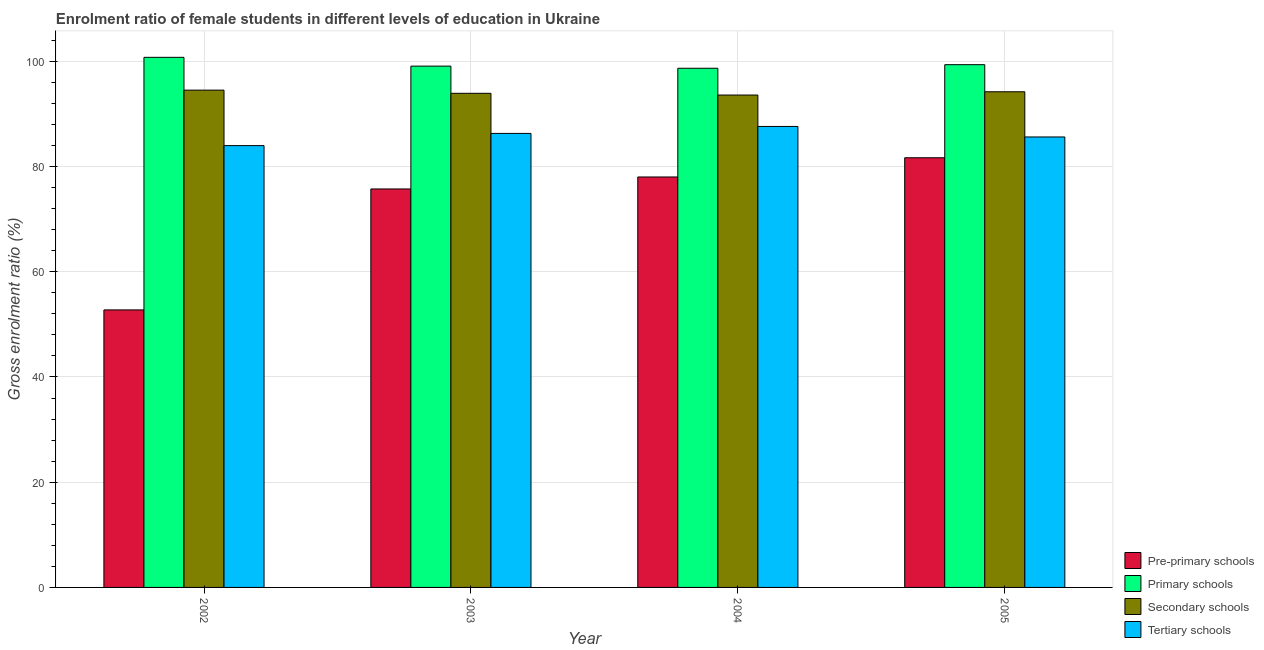How many bars are there on the 1st tick from the right?
Ensure brevity in your answer.  4. What is the label of the 3rd group of bars from the left?
Give a very brief answer. 2004. In how many cases, is the number of bars for a given year not equal to the number of legend labels?
Your answer should be very brief. 0. What is the gross enrolment ratio(male) in pre-primary schools in 2005?
Your answer should be compact. 81.67. Across all years, what is the maximum gross enrolment ratio(male) in primary schools?
Provide a succinct answer. 100.76. Across all years, what is the minimum gross enrolment ratio(male) in tertiary schools?
Offer a terse response. 83.98. In which year was the gross enrolment ratio(male) in tertiary schools maximum?
Make the answer very short. 2004. What is the total gross enrolment ratio(male) in tertiary schools in the graph?
Your answer should be very brief. 343.53. What is the difference between the gross enrolment ratio(male) in pre-primary schools in 2003 and that in 2004?
Your answer should be compact. -2.28. What is the difference between the gross enrolment ratio(male) in primary schools in 2005 and the gross enrolment ratio(male) in pre-primary schools in 2002?
Provide a short and direct response. -1.4. What is the average gross enrolment ratio(male) in tertiary schools per year?
Provide a short and direct response. 85.88. In how many years, is the gross enrolment ratio(male) in tertiary schools greater than 36 %?
Your response must be concise. 4. What is the ratio of the gross enrolment ratio(male) in pre-primary schools in 2004 to that in 2005?
Your answer should be compact. 0.96. What is the difference between the highest and the second highest gross enrolment ratio(male) in secondary schools?
Provide a succinct answer. 0.31. What is the difference between the highest and the lowest gross enrolment ratio(male) in primary schools?
Keep it short and to the point. 2.08. In how many years, is the gross enrolment ratio(male) in secondary schools greater than the average gross enrolment ratio(male) in secondary schools taken over all years?
Provide a short and direct response. 2. What does the 1st bar from the left in 2002 represents?
Ensure brevity in your answer.  Pre-primary schools. What does the 4th bar from the right in 2003 represents?
Ensure brevity in your answer.  Pre-primary schools. How many bars are there?
Give a very brief answer. 16. Are the values on the major ticks of Y-axis written in scientific E-notation?
Offer a terse response. No. Does the graph contain any zero values?
Offer a very short reply. No. Where does the legend appear in the graph?
Offer a very short reply. Bottom right. How many legend labels are there?
Your response must be concise. 4. How are the legend labels stacked?
Your answer should be very brief. Vertical. What is the title of the graph?
Provide a short and direct response. Enrolment ratio of female students in different levels of education in Ukraine. What is the label or title of the X-axis?
Make the answer very short. Year. What is the label or title of the Y-axis?
Your answer should be compact. Gross enrolment ratio (%). What is the Gross enrolment ratio (%) of Pre-primary schools in 2002?
Make the answer very short. 52.75. What is the Gross enrolment ratio (%) of Primary schools in 2002?
Ensure brevity in your answer.  100.76. What is the Gross enrolment ratio (%) of Secondary schools in 2002?
Your answer should be very brief. 94.53. What is the Gross enrolment ratio (%) in Tertiary schools in 2002?
Keep it short and to the point. 83.98. What is the Gross enrolment ratio (%) of Pre-primary schools in 2003?
Keep it short and to the point. 75.74. What is the Gross enrolment ratio (%) in Primary schools in 2003?
Give a very brief answer. 99.09. What is the Gross enrolment ratio (%) of Secondary schools in 2003?
Make the answer very short. 93.92. What is the Gross enrolment ratio (%) in Tertiary schools in 2003?
Your answer should be very brief. 86.3. What is the Gross enrolment ratio (%) of Pre-primary schools in 2004?
Ensure brevity in your answer.  78.02. What is the Gross enrolment ratio (%) of Primary schools in 2004?
Make the answer very short. 98.68. What is the Gross enrolment ratio (%) in Secondary schools in 2004?
Your answer should be very brief. 93.6. What is the Gross enrolment ratio (%) of Tertiary schools in 2004?
Provide a succinct answer. 87.63. What is the Gross enrolment ratio (%) of Pre-primary schools in 2005?
Ensure brevity in your answer.  81.67. What is the Gross enrolment ratio (%) in Primary schools in 2005?
Offer a terse response. 99.37. What is the Gross enrolment ratio (%) of Secondary schools in 2005?
Your answer should be very brief. 94.22. What is the Gross enrolment ratio (%) of Tertiary schools in 2005?
Keep it short and to the point. 85.63. Across all years, what is the maximum Gross enrolment ratio (%) of Pre-primary schools?
Provide a short and direct response. 81.67. Across all years, what is the maximum Gross enrolment ratio (%) in Primary schools?
Ensure brevity in your answer.  100.76. Across all years, what is the maximum Gross enrolment ratio (%) in Secondary schools?
Provide a short and direct response. 94.53. Across all years, what is the maximum Gross enrolment ratio (%) in Tertiary schools?
Offer a very short reply. 87.63. Across all years, what is the minimum Gross enrolment ratio (%) of Pre-primary schools?
Your answer should be very brief. 52.75. Across all years, what is the minimum Gross enrolment ratio (%) in Primary schools?
Provide a short and direct response. 98.68. Across all years, what is the minimum Gross enrolment ratio (%) in Secondary schools?
Give a very brief answer. 93.6. Across all years, what is the minimum Gross enrolment ratio (%) of Tertiary schools?
Your answer should be very brief. 83.98. What is the total Gross enrolment ratio (%) in Pre-primary schools in the graph?
Your answer should be very brief. 288.18. What is the total Gross enrolment ratio (%) of Primary schools in the graph?
Your answer should be compact. 397.9. What is the total Gross enrolment ratio (%) in Secondary schools in the graph?
Provide a short and direct response. 376.26. What is the total Gross enrolment ratio (%) of Tertiary schools in the graph?
Give a very brief answer. 343.53. What is the difference between the Gross enrolment ratio (%) in Pre-primary schools in 2002 and that in 2003?
Offer a very short reply. -22.99. What is the difference between the Gross enrolment ratio (%) in Primary schools in 2002 and that in 2003?
Your response must be concise. 1.67. What is the difference between the Gross enrolment ratio (%) in Secondary schools in 2002 and that in 2003?
Keep it short and to the point. 0.6. What is the difference between the Gross enrolment ratio (%) in Tertiary schools in 2002 and that in 2003?
Provide a short and direct response. -2.32. What is the difference between the Gross enrolment ratio (%) of Pre-primary schools in 2002 and that in 2004?
Your answer should be very brief. -25.27. What is the difference between the Gross enrolment ratio (%) in Primary schools in 2002 and that in 2004?
Your answer should be compact. 2.08. What is the difference between the Gross enrolment ratio (%) in Secondary schools in 2002 and that in 2004?
Provide a succinct answer. 0.93. What is the difference between the Gross enrolment ratio (%) of Tertiary schools in 2002 and that in 2004?
Keep it short and to the point. -3.64. What is the difference between the Gross enrolment ratio (%) in Pre-primary schools in 2002 and that in 2005?
Give a very brief answer. -28.92. What is the difference between the Gross enrolment ratio (%) in Primary schools in 2002 and that in 2005?
Keep it short and to the point. 1.4. What is the difference between the Gross enrolment ratio (%) in Secondary schools in 2002 and that in 2005?
Your answer should be compact. 0.31. What is the difference between the Gross enrolment ratio (%) of Tertiary schools in 2002 and that in 2005?
Your response must be concise. -1.64. What is the difference between the Gross enrolment ratio (%) in Pre-primary schools in 2003 and that in 2004?
Provide a succinct answer. -2.28. What is the difference between the Gross enrolment ratio (%) in Primary schools in 2003 and that in 2004?
Make the answer very short. 0.41. What is the difference between the Gross enrolment ratio (%) in Secondary schools in 2003 and that in 2004?
Provide a short and direct response. 0.33. What is the difference between the Gross enrolment ratio (%) of Tertiary schools in 2003 and that in 2004?
Give a very brief answer. -1.33. What is the difference between the Gross enrolment ratio (%) of Pre-primary schools in 2003 and that in 2005?
Provide a short and direct response. -5.93. What is the difference between the Gross enrolment ratio (%) of Primary schools in 2003 and that in 2005?
Make the answer very short. -0.28. What is the difference between the Gross enrolment ratio (%) of Secondary schools in 2003 and that in 2005?
Offer a very short reply. -0.29. What is the difference between the Gross enrolment ratio (%) in Tertiary schools in 2003 and that in 2005?
Your answer should be compact. 0.67. What is the difference between the Gross enrolment ratio (%) in Pre-primary schools in 2004 and that in 2005?
Your answer should be compact. -3.65. What is the difference between the Gross enrolment ratio (%) of Primary schools in 2004 and that in 2005?
Offer a terse response. -0.68. What is the difference between the Gross enrolment ratio (%) in Secondary schools in 2004 and that in 2005?
Your answer should be compact. -0.62. What is the difference between the Gross enrolment ratio (%) in Tertiary schools in 2004 and that in 2005?
Ensure brevity in your answer.  2. What is the difference between the Gross enrolment ratio (%) in Pre-primary schools in 2002 and the Gross enrolment ratio (%) in Primary schools in 2003?
Keep it short and to the point. -46.34. What is the difference between the Gross enrolment ratio (%) in Pre-primary schools in 2002 and the Gross enrolment ratio (%) in Secondary schools in 2003?
Keep it short and to the point. -41.17. What is the difference between the Gross enrolment ratio (%) of Pre-primary schools in 2002 and the Gross enrolment ratio (%) of Tertiary schools in 2003?
Your response must be concise. -33.55. What is the difference between the Gross enrolment ratio (%) of Primary schools in 2002 and the Gross enrolment ratio (%) of Secondary schools in 2003?
Your answer should be compact. 6.84. What is the difference between the Gross enrolment ratio (%) of Primary schools in 2002 and the Gross enrolment ratio (%) of Tertiary schools in 2003?
Your response must be concise. 14.46. What is the difference between the Gross enrolment ratio (%) in Secondary schools in 2002 and the Gross enrolment ratio (%) in Tertiary schools in 2003?
Offer a very short reply. 8.23. What is the difference between the Gross enrolment ratio (%) in Pre-primary schools in 2002 and the Gross enrolment ratio (%) in Primary schools in 2004?
Provide a succinct answer. -45.93. What is the difference between the Gross enrolment ratio (%) in Pre-primary schools in 2002 and the Gross enrolment ratio (%) in Secondary schools in 2004?
Offer a terse response. -40.84. What is the difference between the Gross enrolment ratio (%) in Pre-primary schools in 2002 and the Gross enrolment ratio (%) in Tertiary schools in 2004?
Give a very brief answer. -34.87. What is the difference between the Gross enrolment ratio (%) in Primary schools in 2002 and the Gross enrolment ratio (%) in Secondary schools in 2004?
Keep it short and to the point. 7.17. What is the difference between the Gross enrolment ratio (%) of Primary schools in 2002 and the Gross enrolment ratio (%) of Tertiary schools in 2004?
Provide a short and direct response. 13.14. What is the difference between the Gross enrolment ratio (%) in Secondary schools in 2002 and the Gross enrolment ratio (%) in Tertiary schools in 2004?
Provide a succinct answer. 6.9. What is the difference between the Gross enrolment ratio (%) in Pre-primary schools in 2002 and the Gross enrolment ratio (%) in Primary schools in 2005?
Your answer should be very brief. -46.61. What is the difference between the Gross enrolment ratio (%) of Pre-primary schools in 2002 and the Gross enrolment ratio (%) of Secondary schools in 2005?
Provide a short and direct response. -41.46. What is the difference between the Gross enrolment ratio (%) of Pre-primary schools in 2002 and the Gross enrolment ratio (%) of Tertiary schools in 2005?
Ensure brevity in your answer.  -32.87. What is the difference between the Gross enrolment ratio (%) in Primary schools in 2002 and the Gross enrolment ratio (%) in Secondary schools in 2005?
Your answer should be compact. 6.55. What is the difference between the Gross enrolment ratio (%) in Primary schools in 2002 and the Gross enrolment ratio (%) in Tertiary schools in 2005?
Your answer should be very brief. 15.14. What is the difference between the Gross enrolment ratio (%) of Secondary schools in 2002 and the Gross enrolment ratio (%) of Tertiary schools in 2005?
Offer a terse response. 8.9. What is the difference between the Gross enrolment ratio (%) of Pre-primary schools in 2003 and the Gross enrolment ratio (%) of Primary schools in 2004?
Your response must be concise. -22.94. What is the difference between the Gross enrolment ratio (%) in Pre-primary schools in 2003 and the Gross enrolment ratio (%) in Secondary schools in 2004?
Ensure brevity in your answer.  -17.85. What is the difference between the Gross enrolment ratio (%) of Pre-primary schools in 2003 and the Gross enrolment ratio (%) of Tertiary schools in 2004?
Provide a short and direct response. -11.88. What is the difference between the Gross enrolment ratio (%) of Primary schools in 2003 and the Gross enrolment ratio (%) of Secondary schools in 2004?
Give a very brief answer. 5.49. What is the difference between the Gross enrolment ratio (%) in Primary schools in 2003 and the Gross enrolment ratio (%) in Tertiary schools in 2004?
Make the answer very short. 11.46. What is the difference between the Gross enrolment ratio (%) in Secondary schools in 2003 and the Gross enrolment ratio (%) in Tertiary schools in 2004?
Ensure brevity in your answer.  6.3. What is the difference between the Gross enrolment ratio (%) in Pre-primary schools in 2003 and the Gross enrolment ratio (%) in Primary schools in 2005?
Your answer should be compact. -23.62. What is the difference between the Gross enrolment ratio (%) of Pre-primary schools in 2003 and the Gross enrolment ratio (%) of Secondary schools in 2005?
Your response must be concise. -18.47. What is the difference between the Gross enrolment ratio (%) of Pre-primary schools in 2003 and the Gross enrolment ratio (%) of Tertiary schools in 2005?
Provide a short and direct response. -9.88. What is the difference between the Gross enrolment ratio (%) in Primary schools in 2003 and the Gross enrolment ratio (%) in Secondary schools in 2005?
Your response must be concise. 4.87. What is the difference between the Gross enrolment ratio (%) in Primary schools in 2003 and the Gross enrolment ratio (%) in Tertiary schools in 2005?
Your response must be concise. 13.46. What is the difference between the Gross enrolment ratio (%) of Secondary schools in 2003 and the Gross enrolment ratio (%) of Tertiary schools in 2005?
Make the answer very short. 8.3. What is the difference between the Gross enrolment ratio (%) in Pre-primary schools in 2004 and the Gross enrolment ratio (%) in Primary schools in 2005?
Give a very brief answer. -21.35. What is the difference between the Gross enrolment ratio (%) of Pre-primary schools in 2004 and the Gross enrolment ratio (%) of Secondary schools in 2005?
Make the answer very short. -16.2. What is the difference between the Gross enrolment ratio (%) in Pre-primary schools in 2004 and the Gross enrolment ratio (%) in Tertiary schools in 2005?
Make the answer very short. -7.61. What is the difference between the Gross enrolment ratio (%) of Primary schools in 2004 and the Gross enrolment ratio (%) of Secondary schools in 2005?
Provide a succinct answer. 4.47. What is the difference between the Gross enrolment ratio (%) in Primary schools in 2004 and the Gross enrolment ratio (%) in Tertiary schools in 2005?
Your response must be concise. 13.06. What is the difference between the Gross enrolment ratio (%) of Secondary schools in 2004 and the Gross enrolment ratio (%) of Tertiary schools in 2005?
Offer a terse response. 7.97. What is the average Gross enrolment ratio (%) in Pre-primary schools per year?
Keep it short and to the point. 72.05. What is the average Gross enrolment ratio (%) in Primary schools per year?
Provide a short and direct response. 99.48. What is the average Gross enrolment ratio (%) in Secondary schools per year?
Make the answer very short. 94.07. What is the average Gross enrolment ratio (%) in Tertiary schools per year?
Your answer should be very brief. 85.88. In the year 2002, what is the difference between the Gross enrolment ratio (%) of Pre-primary schools and Gross enrolment ratio (%) of Primary schools?
Give a very brief answer. -48.01. In the year 2002, what is the difference between the Gross enrolment ratio (%) of Pre-primary schools and Gross enrolment ratio (%) of Secondary schools?
Your answer should be compact. -41.78. In the year 2002, what is the difference between the Gross enrolment ratio (%) in Pre-primary schools and Gross enrolment ratio (%) in Tertiary schools?
Your answer should be very brief. -31.23. In the year 2002, what is the difference between the Gross enrolment ratio (%) of Primary schools and Gross enrolment ratio (%) of Secondary schools?
Your response must be concise. 6.23. In the year 2002, what is the difference between the Gross enrolment ratio (%) of Primary schools and Gross enrolment ratio (%) of Tertiary schools?
Your answer should be very brief. 16.78. In the year 2002, what is the difference between the Gross enrolment ratio (%) in Secondary schools and Gross enrolment ratio (%) in Tertiary schools?
Offer a terse response. 10.55. In the year 2003, what is the difference between the Gross enrolment ratio (%) in Pre-primary schools and Gross enrolment ratio (%) in Primary schools?
Your response must be concise. -23.35. In the year 2003, what is the difference between the Gross enrolment ratio (%) of Pre-primary schools and Gross enrolment ratio (%) of Secondary schools?
Ensure brevity in your answer.  -18.18. In the year 2003, what is the difference between the Gross enrolment ratio (%) of Pre-primary schools and Gross enrolment ratio (%) of Tertiary schools?
Provide a short and direct response. -10.56. In the year 2003, what is the difference between the Gross enrolment ratio (%) of Primary schools and Gross enrolment ratio (%) of Secondary schools?
Provide a succinct answer. 5.17. In the year 2003, what is the difference between the Gross enrolment ratio (%) in Primary schools and Gross enrolment ratio (%) in Tertiary schools?
Make the answer very short. 12.79. In the year 2003, what is the difference between the Gross enrolment ratio (%) of Secondary schools and Gross enrolment ratio (%) of Tertiary schools?
Your answer should be very brief. 7.62. In the year 2004, what is the difference between the Gross enrolment ratio (%) of Pre-primary schools and Gross enrolment ratio (%) of Primary schools?
Provide a succinct answer. -20.66. In the year 2004, what is the difference between the Gross enrolment ratio (%) of Pre-primary schools and Gross enrolment ratio (%) of Secondary schools?
Make the answer very short. -15.58. In the year 2004, what is the difference between the Gross enrolment ratio (%) in Pre-primary schools and Gross enrolment ratio (%) in Tertiary schools?
Your response must be concise. -9.61. In the year 2004, what is the difference between the Gross enrolment ratio (%) in Primary schools and Gross enrolment ratio (%) in Secondary schools?
Make the answer very short. 5.09. In the year 2004, what is the difference between the Gross enrolment ratio (%) of Primary schools and Gross enrolment ratio (%) of Tertiary schools?
Offer a terse response. 11.06. In the year 2004, what is the difference between the Gross enrolment ratio (%) of Secondary schools and Gross enrolment ratio (%) of Tertiary schools?
Provide a succinct answer. 5.97. In the year 2005, what is the difference between the Gross enrolment ratio (%) of Pre-primary schools and Gross enrolment ratio (%) of Primary schools?
Provide a short and direct response. -17.69. In the year 2005, what is the difference between the Gross enrolment ratio (%) of Pre-primary schools and Gross enrolment ratio (%) of Secondary schools?
Your answer should be very brief. -12.54. In the year 2005, what is the difference between the Gross enrolment ratio (%) of Pre-primary schools and Gross enrolment ratio (%) of Tertiary schools?
Make the answer very short. -3.95. In the year 2005, what is the difference between the Gross enrolment ratio (%) of Primary schools and Gross enrolment ratio (%) of Secondary schools?
Ensure brevity in your answer.  5.15. In the year 2005, what is the difference between the Gross enrolment ratio (%) in Primary schools and Gross enrolment ratio (%) in Tertiary schools?
Keep it short and to the point. 13.74. In the year 2005, what is the difference between the Gross enrolment ratio (%) in Secondary schools and Gross enrolment ratio (%) in Tertiary schools?
Give a very brief answer. 8.59. What is the ratio of the Gross enrolment ratio (%) in Pre-primary schools in 2002 to that in 2003?
Offer a very short reply. 0.7. What is the ratio of the Gross enrolment ratio (%) of Primary schools in 2002 to that in 2003?
Keep it short and to the point. 1.02. What is the ratio of the Gross enrolment ratio (%) in Secondary schools in 2002 to that in 2003?
Give a very brief answer. 1.01. What is the ratio of the Gross enrolment ratio (%) of Tertiary schools in 2002 to that in 2003?
Give a very brief answer. 0.97. What is the ratio of the Gross enrolment ratio (%) in Pre-primary schools in 2002 to that in 2004?
Provide a succinct answer. 0.68. What is the ratio of the Gross enrolment ratio (%) of Primary schools in 2002 to that in 2004?
Make the answer very short. 1.02. What is the ratio of the Gross enrolment ratio (%) in Secondary schools in 2002 to that in 2004?
Provide a succinct answer. 1.01. What is the ratio of the Gross enrolment ratio (%) in Tertiary schools in 2002 to that in 2004?
Your answer should be very brief. 0.96. What is the ratio of the Gross enrolment ratio (%) of Pre-primary schools in 2002 to that in 2005?
Provide a succinct answer. 0.65. What is the ratio of the Gross enrolment ratio (%) of Primary schools in 2002 to that in 2005?
Keep it short and to the point. 1.01. What is the ratio of the Gross enrolment ratio (%) in Tertiary schools in 2002 to that in 2005?
Give a very brief answer. 0.98. What is the ratio of the Gross enrolment ratio (%) of Pre-primary schools in 2003 to that in 2004?
Provide a succinct answer. 0.97. What is the ratio of the Gross enrolment ratio (%) in Tertiary schools in 2003 to that in 2004?
Provide a short and direct response. 0.98. What is the ratio of the Gross enrolment ratio (%) of Pre-primary schools in 2003 to that in 2005?
Make the answer very short. 0.93. What is the ratio of the Gross enrolment ratio (%) of Tertiary schools in 2003 to that in 2005?
Your answer should be compact. 1.01. What is the ratio of the Gross enrolment ratio (%) of Pre-primary schools in 2004 to that in 2005?
Provide a succinct answer. 0.96. What is the ratio of the Gross enrolment ratio (%) in Tertiary schools in 2004 to that in 2005?
Provide a succinct answer. 1.02. What is the difference between the highest and the second highest Gross enrolment ratio (%) of Pre-primary schools?
Your response must be concise. 3.65. What is the difference between the highest and the second highest Gross enrolment ratio (%) of Primary schools?
Make the answer very short. 1.4. What is the difference between the highest and the second highest Gross enrolment ratio (%) in Secondary schools?
Your response must be concise. 0.31. What is the difference between the highest and the second highest Gross enrolment ratio (%) in Tertiary schools?
Offer a very short reply. 1.33. What is the difference between the highest and the lowest Gross enrolment ratio (%) in Pre-primary schools?
Ensure brevity in your answer.  28.92. What is the difference between the highest and the lowest Gross enrolment ratio (%) in Primary schools?
Offer a very short reply. 2.08. What is the difference between the highest and the lowest Gross enrolment ratio (%) of Secondary schools?
Provide a succinct answer. 0.93. What is the difference between the highest and the lowest Gross enrolment ratio (%) of Tertiary schools?
Your answer should be compact. 3.64. 